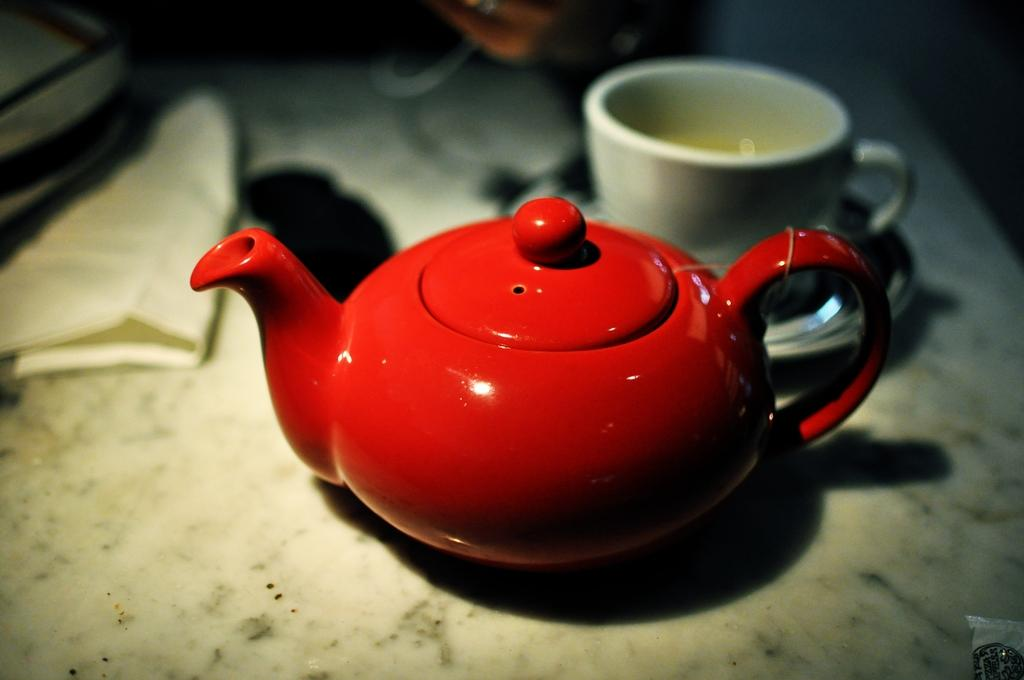What is the main object in the image? There is a kettle in the image. What other object is visible in the image? There is a cup in the image. Where are these objects located? They are on a platform in the image. How would you describe the background of the image? The background of the image is blurry. What type of boot is being used to stir the contents of the kettle in the image? There is no boot present in the image, and the kettle's contents are not being stirred. 